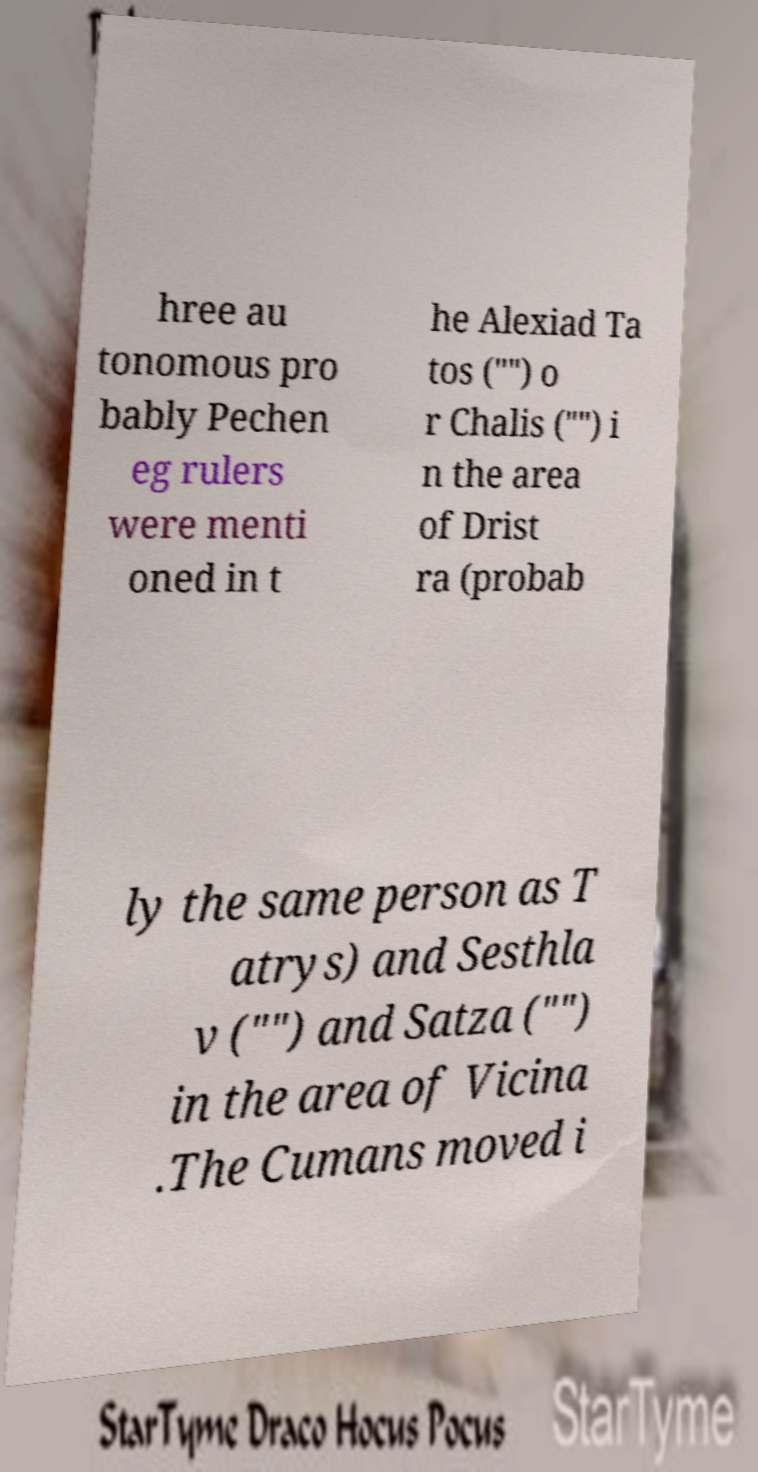What messages or text are displayed in this image? I need them in a readable, typed format. hree au tonomous pro bably Pechen eg rulers were menti oned in t he Alexiad Ta tos ("") o r Chalis ("") i n the area of Drist ra (probab ly the same person as T atrys) and Sesthla v ("") and Satza ("") in the area of Vicina .The Cumans moved i 